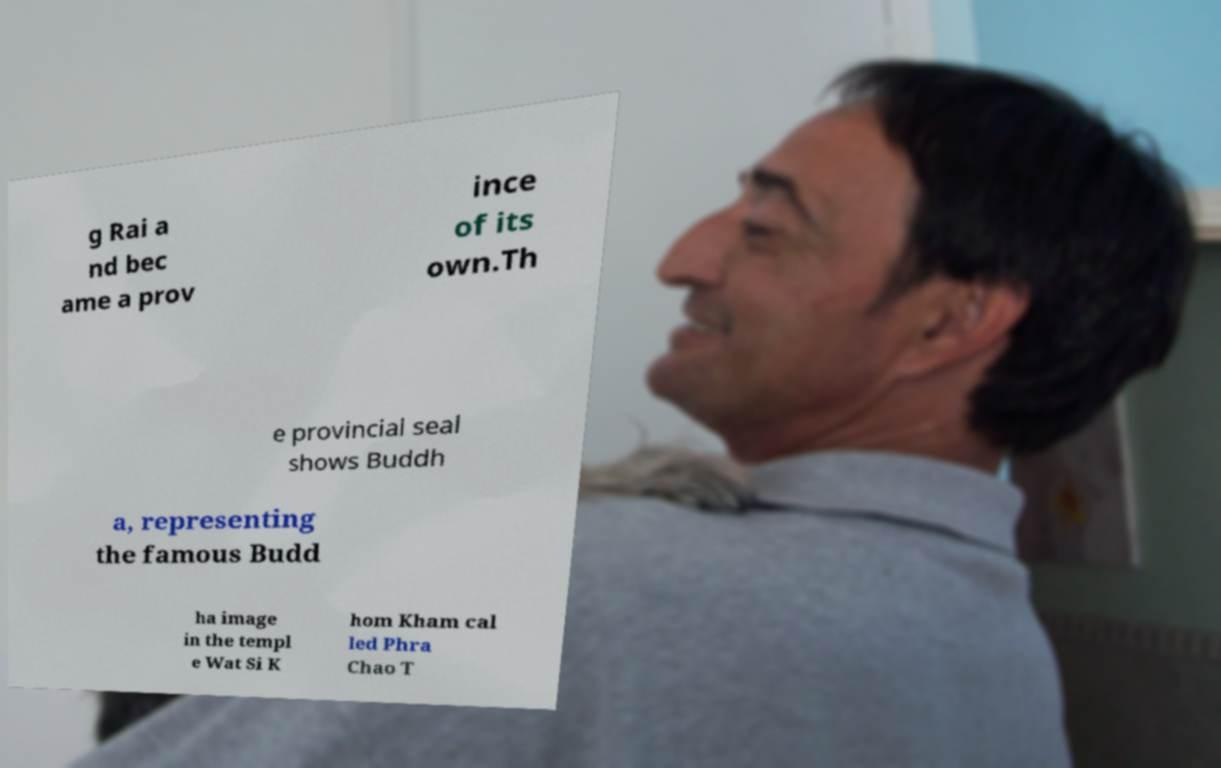For documentation purposes, I need the text within this image transcribed. Could you provide that? g Rai a nd bec ame a prov ince of its own.Th e provincial seal shows Buddh a, representing the famous Budd ha image in the templ e Wat Si K hom Kham cal led Phra Chao T 